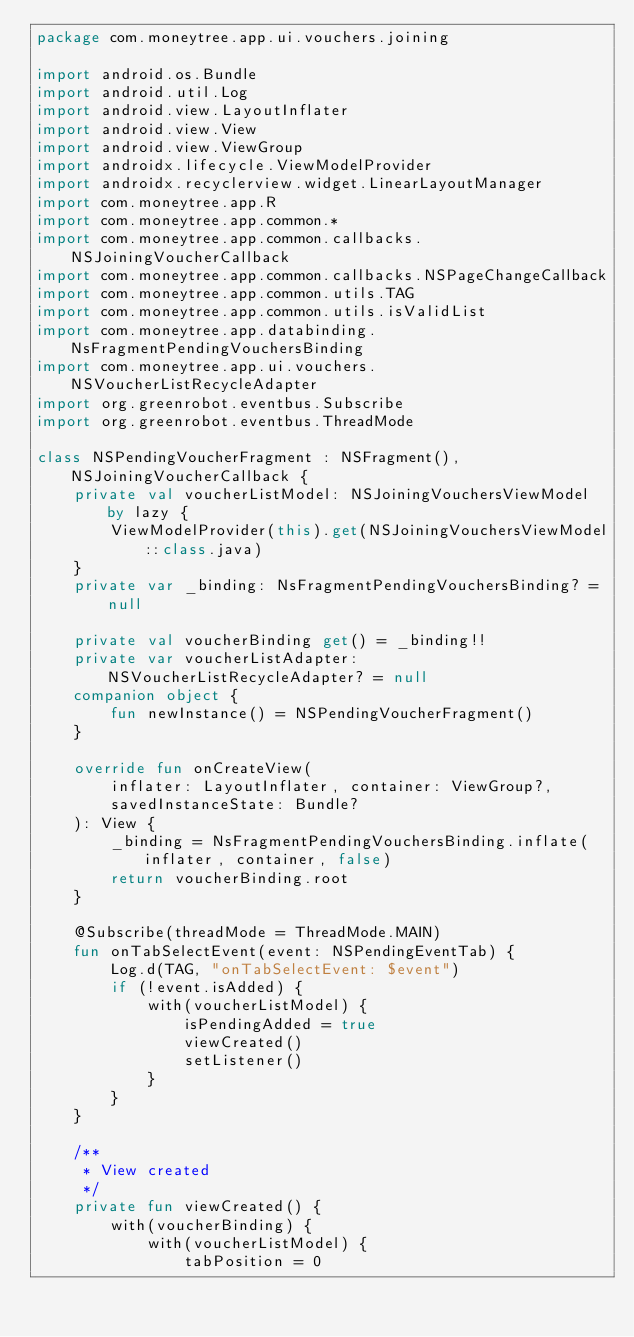<code> <loc_0><loc_0><loc_500><loc_500><_Kotlin_>package com.moneytree.app.ui.vouchers.joining

import android.os.Bundle
import android.util.Log
import android.view.LayoutInflater
import android.view.View
import android.view.ViewGroup
import androidx.lifecycle.ViewModelProvider
import androidx.recyclerview.widget.LinearLayoutManager
import com.moneytree.app.R
import com.moneytree.app.common.*
import com.moneytree.app.common.callbacks.NSJoiningVoucherCallback
import com.moneytree.app.common.callbacks.NSPageChangeCallback
import com.moneytree.app.common.utils.TAG
import com.moneytree.app.common.utils.isValidList
import com.moneytree.app.databinding.NsFragmentPendingVouchersBinding
import com.moneytree.app.ui.vouchers.NSVoucherListRecycleAdapter
import org.greenrobot.eventbus.Subscribe
import org.greenrobot.eventbus.ThreadMode

class NSPendingVoucherFragment : NSFragment(), NSJoiningVoucherCallback {
    private val voucherListModel: NSJoiningVouchersViewModel by lazy {
        ViewModelProvider(this).get(NSJoiningVouchersViewModel::class.java)
    }
    private var _binding: NsFragmentPendingVouchersBinding? = null

    private val voucherBinding get() = _binding!!
    private var voucherListAdapter: NSVoucherListRecycleAdapter? = null
    companion object {
        fun newInstance() = NSPendingVoucherFragment()
    }

    override fun onCreateView(
        inflater: LayoutInflater, container: ViewGroup?,
        savedInstanceState: Bundle?
    ): View {
        _binding = NsFragmentPendingVouchersBinding.inflate(inflater, container, false)
        return voucherBinding.root
    }

    @Subscribe(threadMode = ThreadMode.MAIN)
    fun onTabSelectEvent(event: NSPendingEventTab) {
        Log.d(TAG, "onTabSelectEvent: $event")
        if (!event.isAdded) {
            with(voucherListModel) {
                isPendingAdded = true
                viewCreated()
                setListener()
            }
        }
    }

    /**
     * View created
     */
    private fun viewCreated() {
        with(voucherBinding) {
            with(voucherListModel) {
                tabPosition = 0</code> 